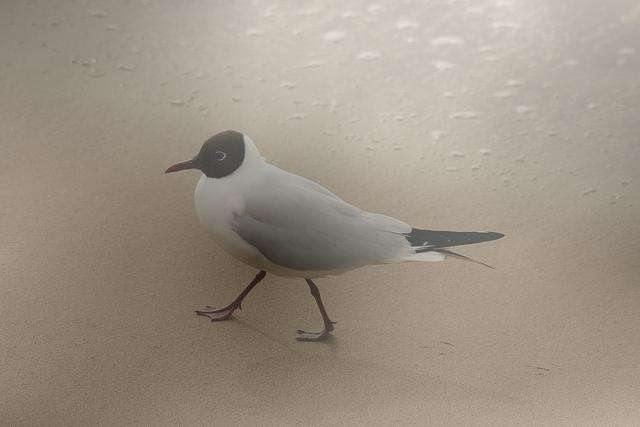Is the composition centered?
A. No
B. Yes
Answer with the option's letter from the given choices directly.
 B. 